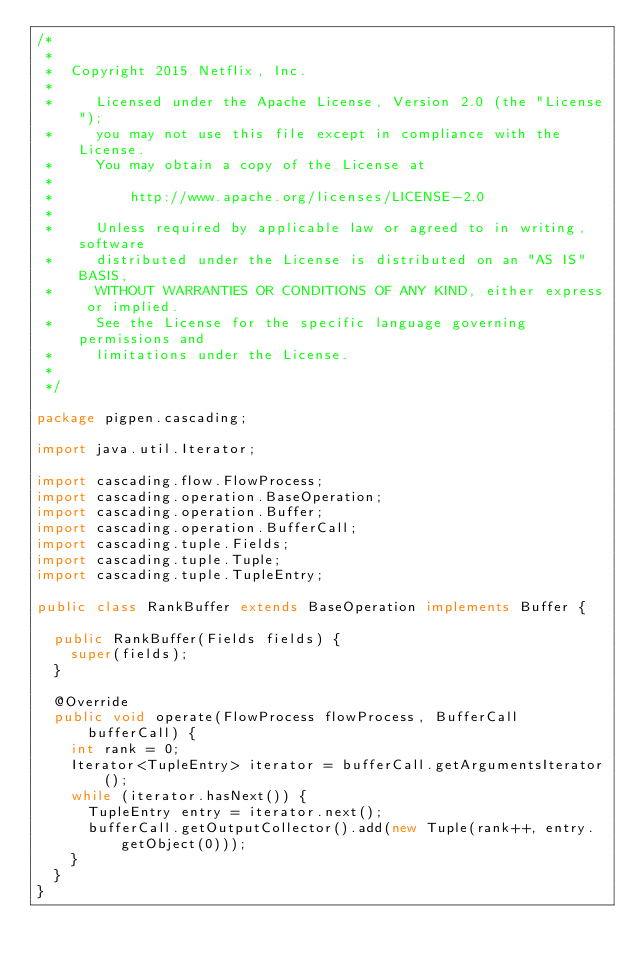Convert code to text. <code><loc_0><loc_0><loc_500><loc_500><_Java_>/*
 *
 *  Copyright 2015 Netflix, Inc.
 *
 *     Licensed under the Apache License, Version 2.0 (the "License");
 *     you may not use this file except in compliance with the License.
 *     You may obtain a copy of the License at
 *
 *         http://www.apache.org/licenses/LICENSE-2.0
 *
 *     Unless required by applicable law or agreed to in writing, software
 *     distributed under the License is distributed on an "AS IS" BASIS,
 *     WITHOUT WARRANTIES OR CONDITIONS OF ANY KIND, either express or implied.
 *     See the License for the specific language governing permissions and
 *     limitations under the License.
 *
 */

package pigpen.cascading;

import java.util.Iterator;

import cascading.flow.FlowProcess;
import cascading.operation.BaseOperation;
import cascading.operation.Buffer;
import cascading.operation.BufferCall;
import cascading.tuple.Fields;
import cascading.tuple.Tuple;
import cascading.tuple.TupleEntry;

public class RankBuffer extends BaseOperation implements Buffer {

  public RankBuffer(Fields fields) {
    super(fields);
  }

  @Override
  public void operate(FlowProcess flowProcess, BufferCall bufferCall) {
    int rank = 0;
    Iterator<TupleEntry> iterator = bufferCall.getArgumentsIterator();
    while (iterator.hasNext()) {
      TupleEntry entry = iterator.next();
      bufferCall.getOutputCollector().add(new Tuple(rank++, entry.getObject(0)));
    }
  }
}
</code> 